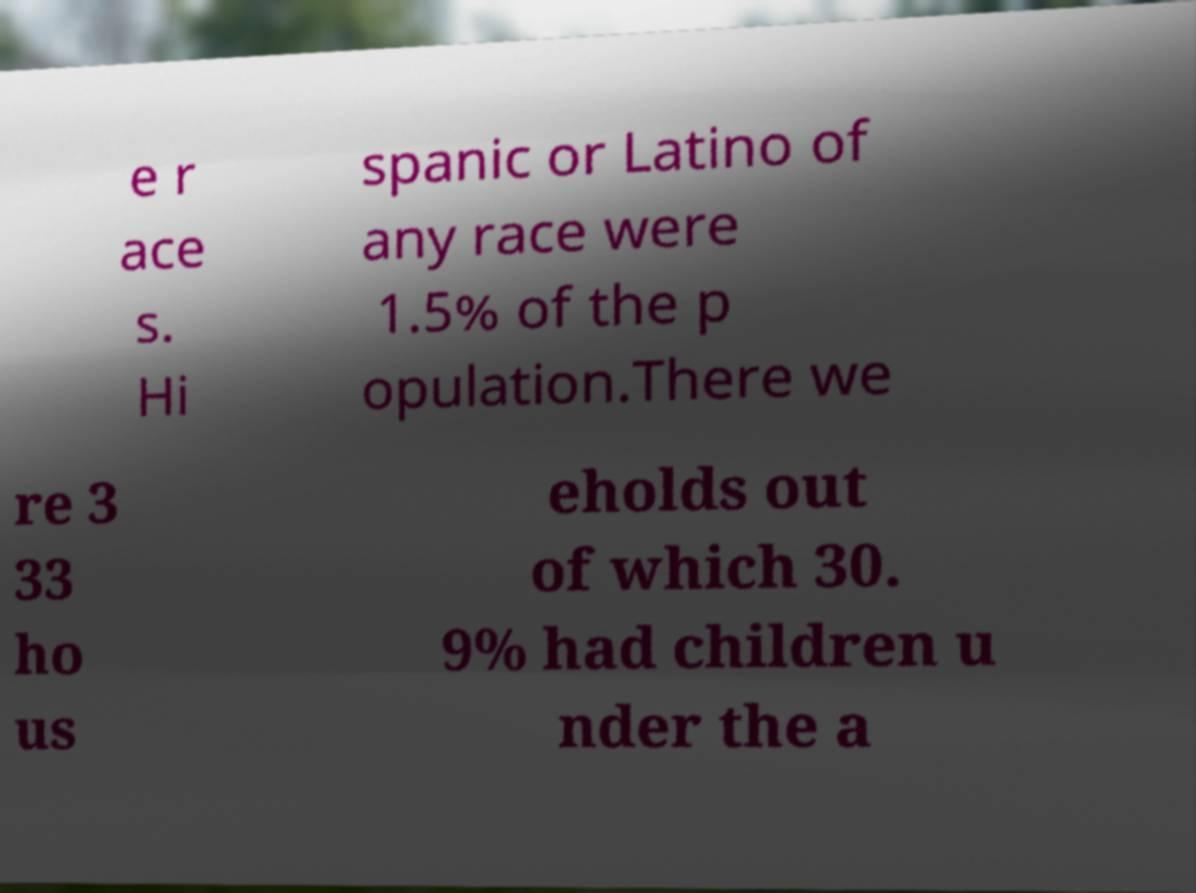I need the written content from this picture converted into text. Can you do that? e r ace s. Hi spanic or Latino of any race were 1.5% of the p opulation.There we re 3 33 ho us eholds out of which 30. 9% had children u nder the a 